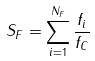<formula> <loc_0><loc_0><loc_500><loc_500>S _ { F } = \sum _ { i = 1 } ^ { N _ { F } } \frac { f _ { i } } { f _ { C } }</formula> 